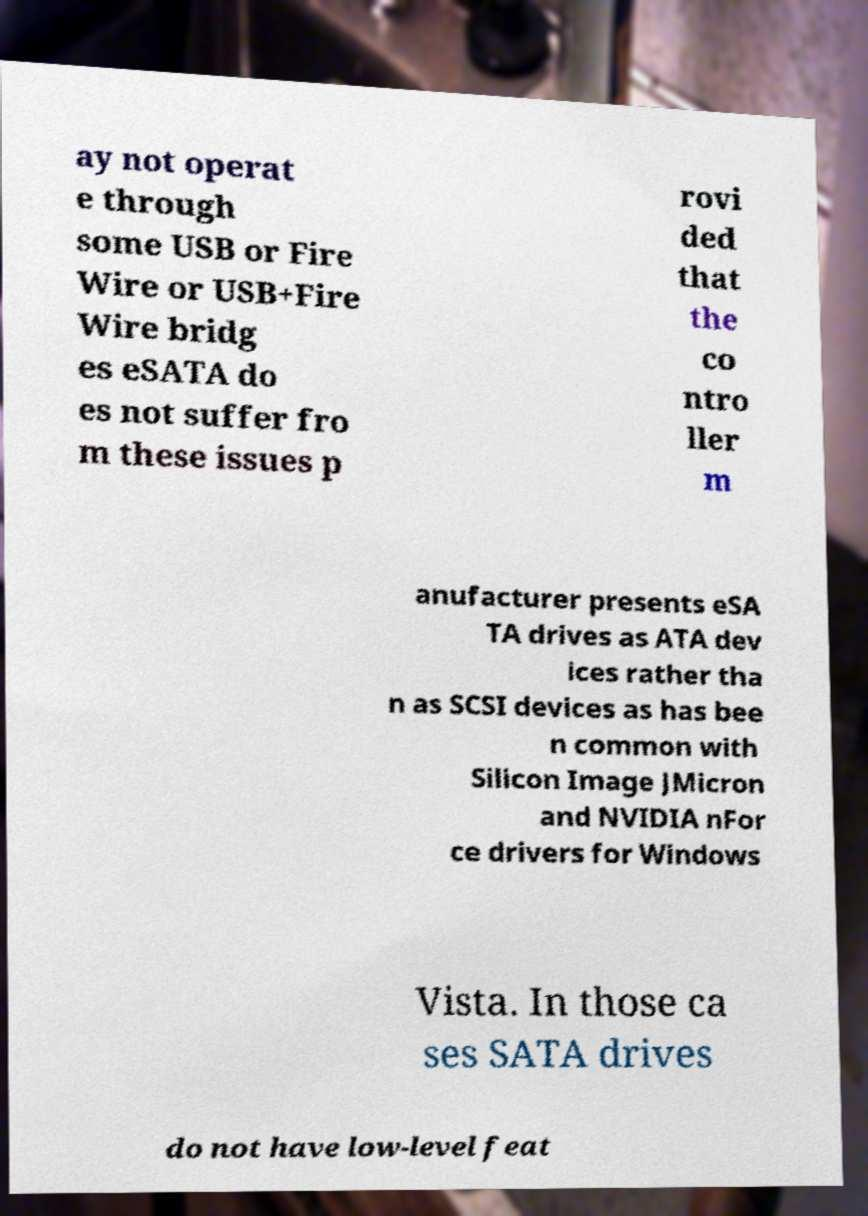There's text embedded in this image that I need extracted. Can you transcribe it verbatim? ay not operat e through some USB or Fire Wire or USB+Fire Wire bridg es eSATA do es not suffer fro m these issues p rovi ded that the co ntro ller m anufacturer presents eSA TA drives as ATA dev ices rather tha n as SCSI devices as has bee n common with Silicon Image JMicron and NVIDIA nFor ce drivers for Windows Vista. In those ca ses SATA drives do not have low-level feat 